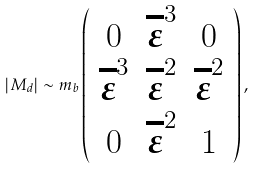<formula> <loc_0><loc_0><loc_500><loc_500>| M _ { d } | \sim m _ { b } \left ( \begin{array} { c c c } 0 & \overline { \varepsilon } ^ { 3 } & 0 \\ \overline { \varepsilon } ^ { 3 } & \overline { \varepsilon } ^ { 2 } & \overline { \varepsilon } ^ { 2 } \\ 0 & \overline { \varepsilon } ^ { 2 } & 1 \\ \end{array} \right ) ,</formula> 